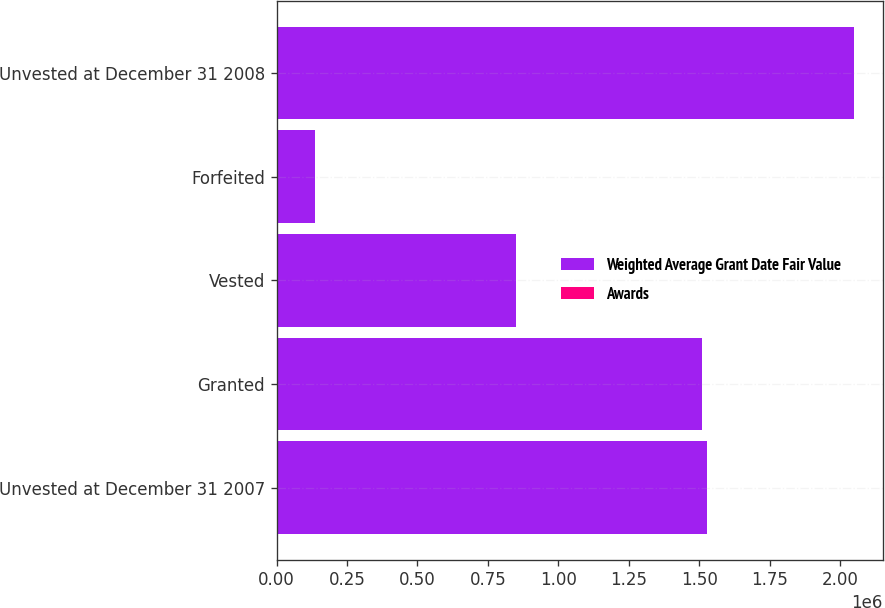Convert chart to OTSL. <chart><loc_0><loc_0><loc_500><loc_500><stacked_bar_chart><ecel><fcel>Unvested at December 31 2007<fcel>Granted<fcel>Vested<fcel>Forfeited<fcel>Unvested at December 31 2008<nl><fcel>Weighted Average Grant Date Fair Value<fcel>1.52783e+06<fcel>1.51038e+06<fcel>851545<fcel>137409<fcel>2.04926e+06<nl><fcel>Awards<fcel>39.87<fcel>46.85<fcel>32.77<fcel>43.52<fcel>47.72<nl></chart> 